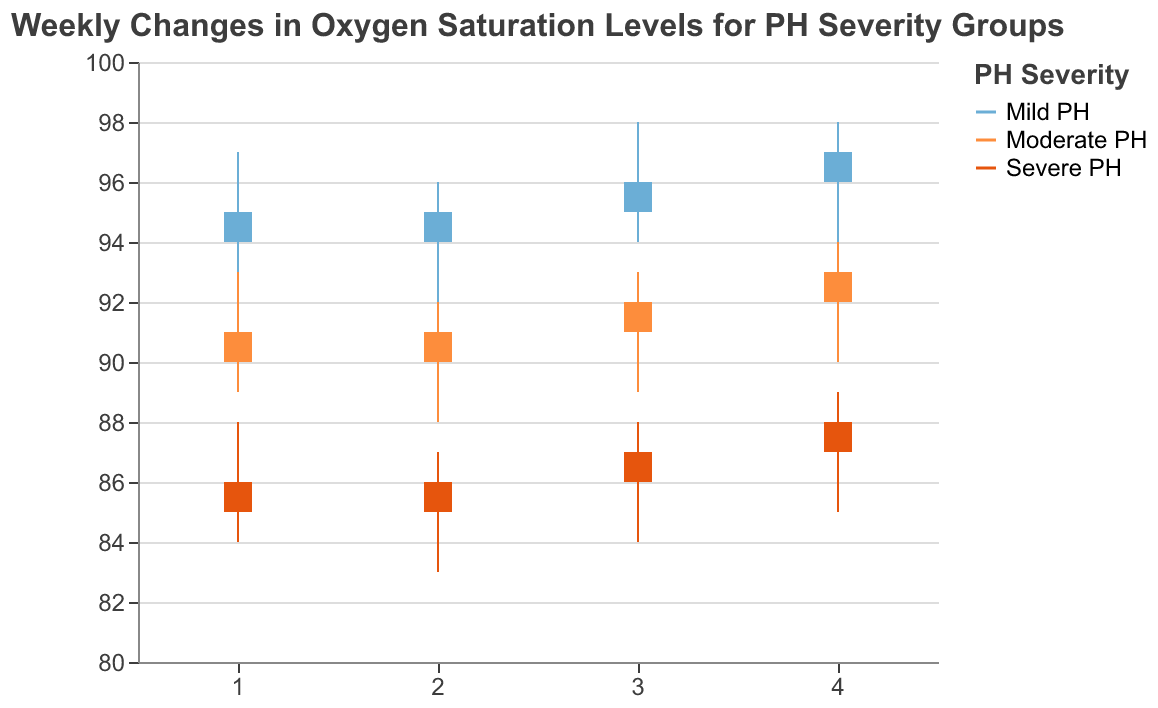What is the title of the figure? The title of the figure can be found at the top of the chart. It reads "Weekly Changes in Oxygen Saturation Levels for PH Severity Groups."
Answer: Weekly Changes in Oxygen Saturation Levels for PH Severity Groups What is the range of oxygen saturation levels for the "Severe PH" group in Week 1? The range is given by the difference between the highest and lowest values for the "Severe PH" group in Week 1. The High is 88 and the Low is 84. So, the range is 88 - 84.
Answer: 4 Which group had the highest closing oxygen saturation level in Week 4? To determine this, we check the closing values for all groups in Week 4. "Mild PH" closes at 97, "Moderate PH" at 93, and "Severe PH" at 88. The highest value is 97 for "Mild PH".
Answer: Mild PH How does the closing oxygen saturation level of "Moderate PH" in Week 2 compare to its opening level in the same week? For Week 2, the "Moderate PH" group's Open is 90 and the Close is 91. The closing level (91) is 1 unit higher than the opening level (90).
Answer: 1 unit higher What is the average of the closing oxygen saturation levels for the "Mild PH" group across all weeks? To find the average, we sum the closing levels for "Mild PH" across all weeks and divide by the number of weeks: (94 + 95 + 96 + 97) / 4 = 382 / 4 = 95.5.
Answer: 95.5 Which group’s oxygen saturation levels showed the least fluctuation (difference between High and Low) during Week 3? We compare the fluctuation (High - Low) for each group in Week 3: "Mild PH" (98 - 94 = 4), "Moderate PH" (93 - 89 = 4), and "Severe PH" (88 - 84 = 4). All groups showed the same fluctuation.
Answer: All groups Compare the opening and closing oxygen saturation levels for the "Severe PH" group in Week 4. How much did it change? In Week 4, the "Severe PH" group's opening level is 87 and closing level is 88. The difference is 88 - 87.
Answer: 1 unit increase What was the trend in the closing oxygen saturation levels for the "Moderate PH" group over the four weeks? The closing levels for "Moderate PH" over the weeks are 90, 91, 92, and 93. There is a consistent increase each week by 1 unit.
Answer: Consistent increase For Week 2, what is the range of oxygen saturation levels for the "Moderate PH" and "Severe PH" groups, and which group had a larger range? The range for "Moderate PH" in Week 2 is 92 - 88 = 4, and for "Severe PH" it is 87 - 83 = 4. Both groups had the same range.
Answer: Both had the same range What is the difference in the closing oxygen saturation levels between the "Mild PH" and "Severe PH" groups in Week 3? For Week 3, the closing level of the "Mild PH" group is 96 and the "Severe PH" group is 87. The difference is 96 - 87.
Answer: 9 